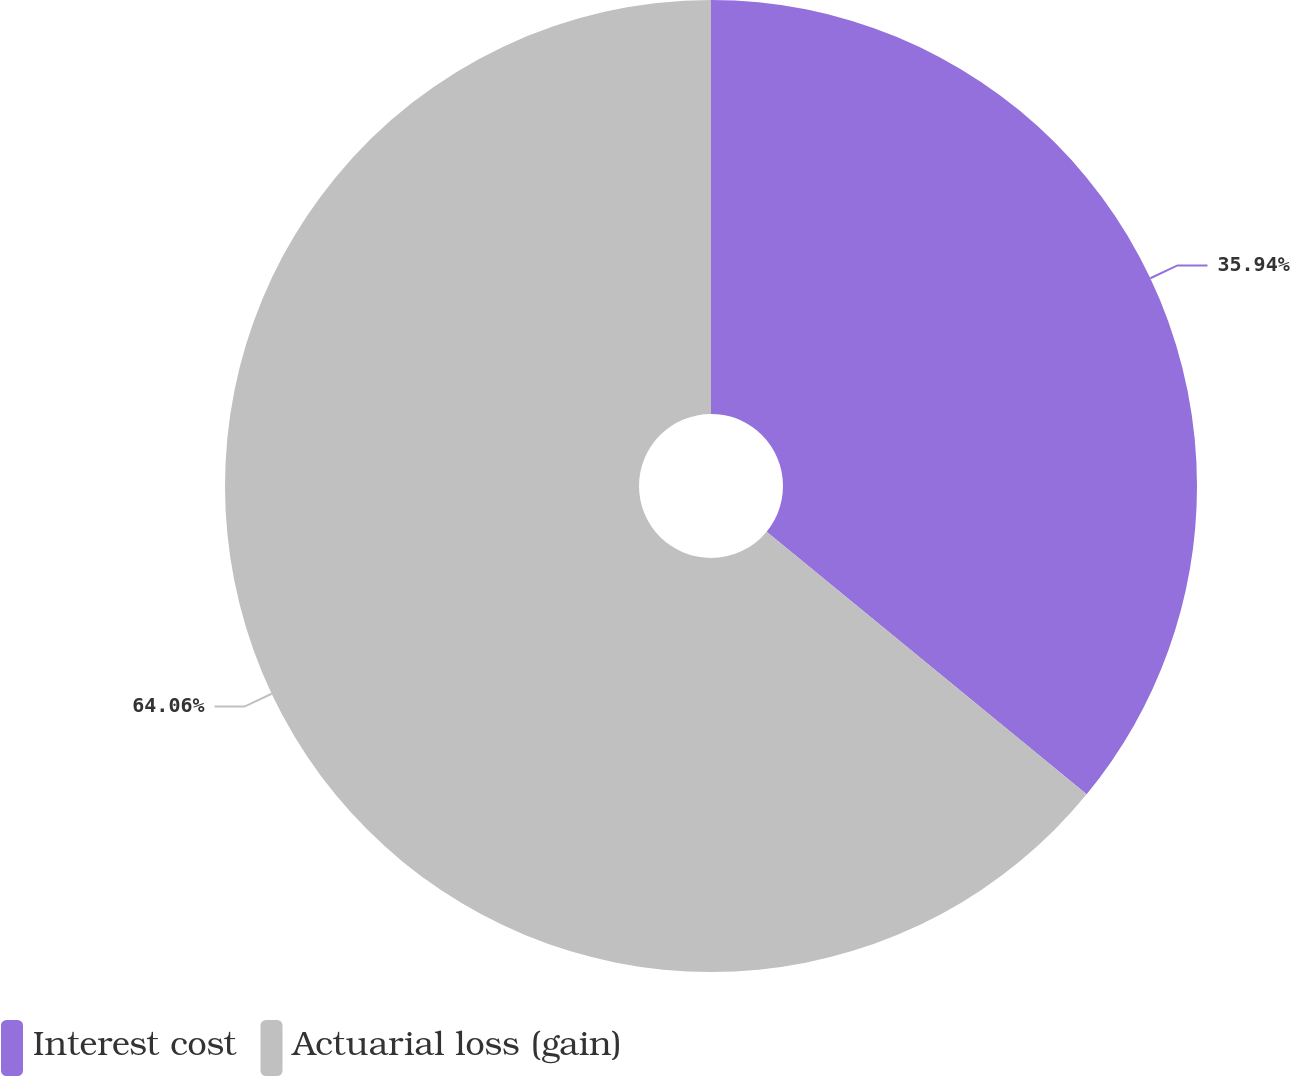Convert chart. <chart><loc_0><loc_0><loc_500><loc_500><pie_chart><fcel>Interest cost<fcel>Actuarial loss (gain)<nl><fcel>35.94%<fcel>64.06%<nl></chart> 